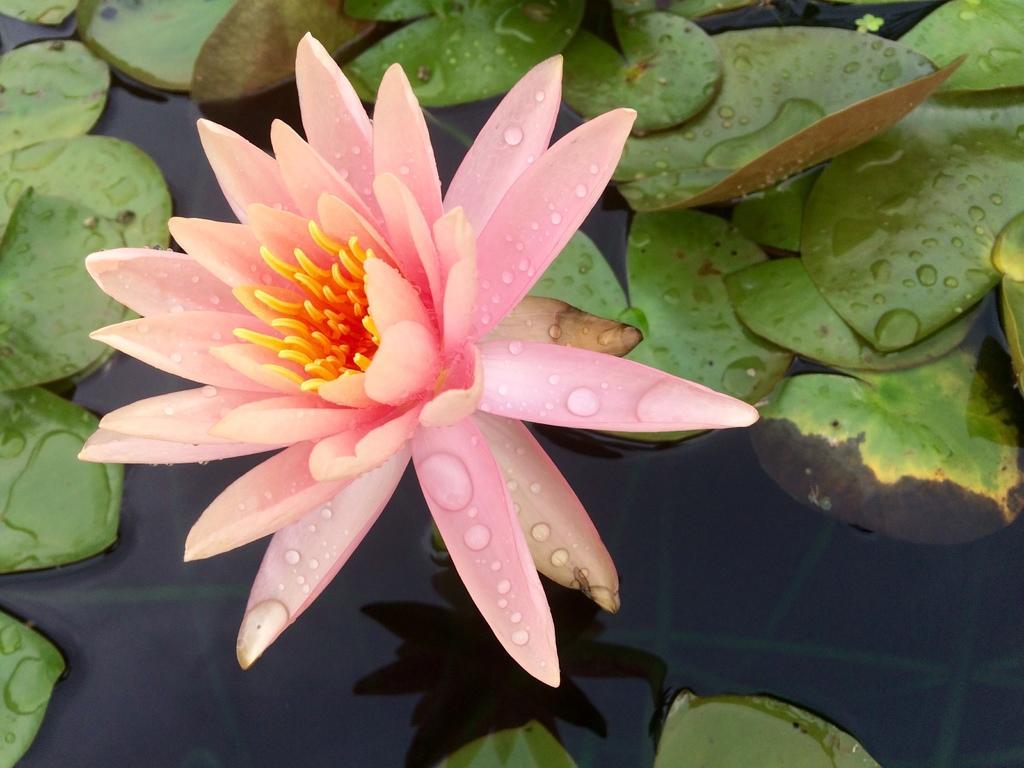Can you describe this image briefly? As we can see in the image there is water, leaves and pink color flower. 